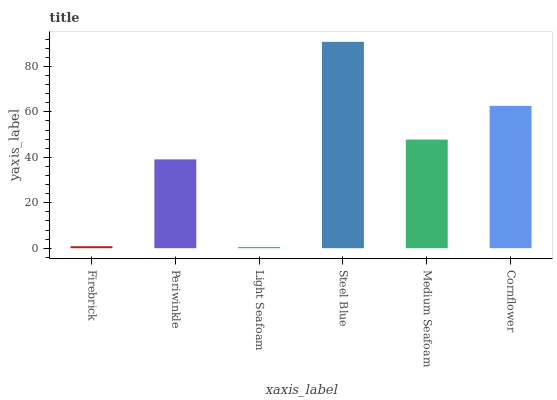Is Light Seafoam the minimum?
Answer yes or no. Yes. Is Steel Blue the maximum?
Answer yes or no. Yes. Is Periwinkle the minimum?
Answer yes or no. No. Is Periwinkle the maximum?
Answer yes or no. No. Is Periwinkle greater than Firebrick?
Answer yes or no. Yes. Is Firebrick less than Periwinkle?
Answer yes or no. Yes. Is Firebrick greater than Periwinkle?
Answer yes or no. No. Is Periwinkle less than Firebrick?
Answer yes or no. No. Is Medium Seafoam the high median?
Answer yes or no. Yes. Is Periwinkle the low median?
Answer yes or no. Yes. Is Steel Blue the high median?
Answer yes or no. No. Is Light Seafoam the low median?
Answer yes or no. No. 